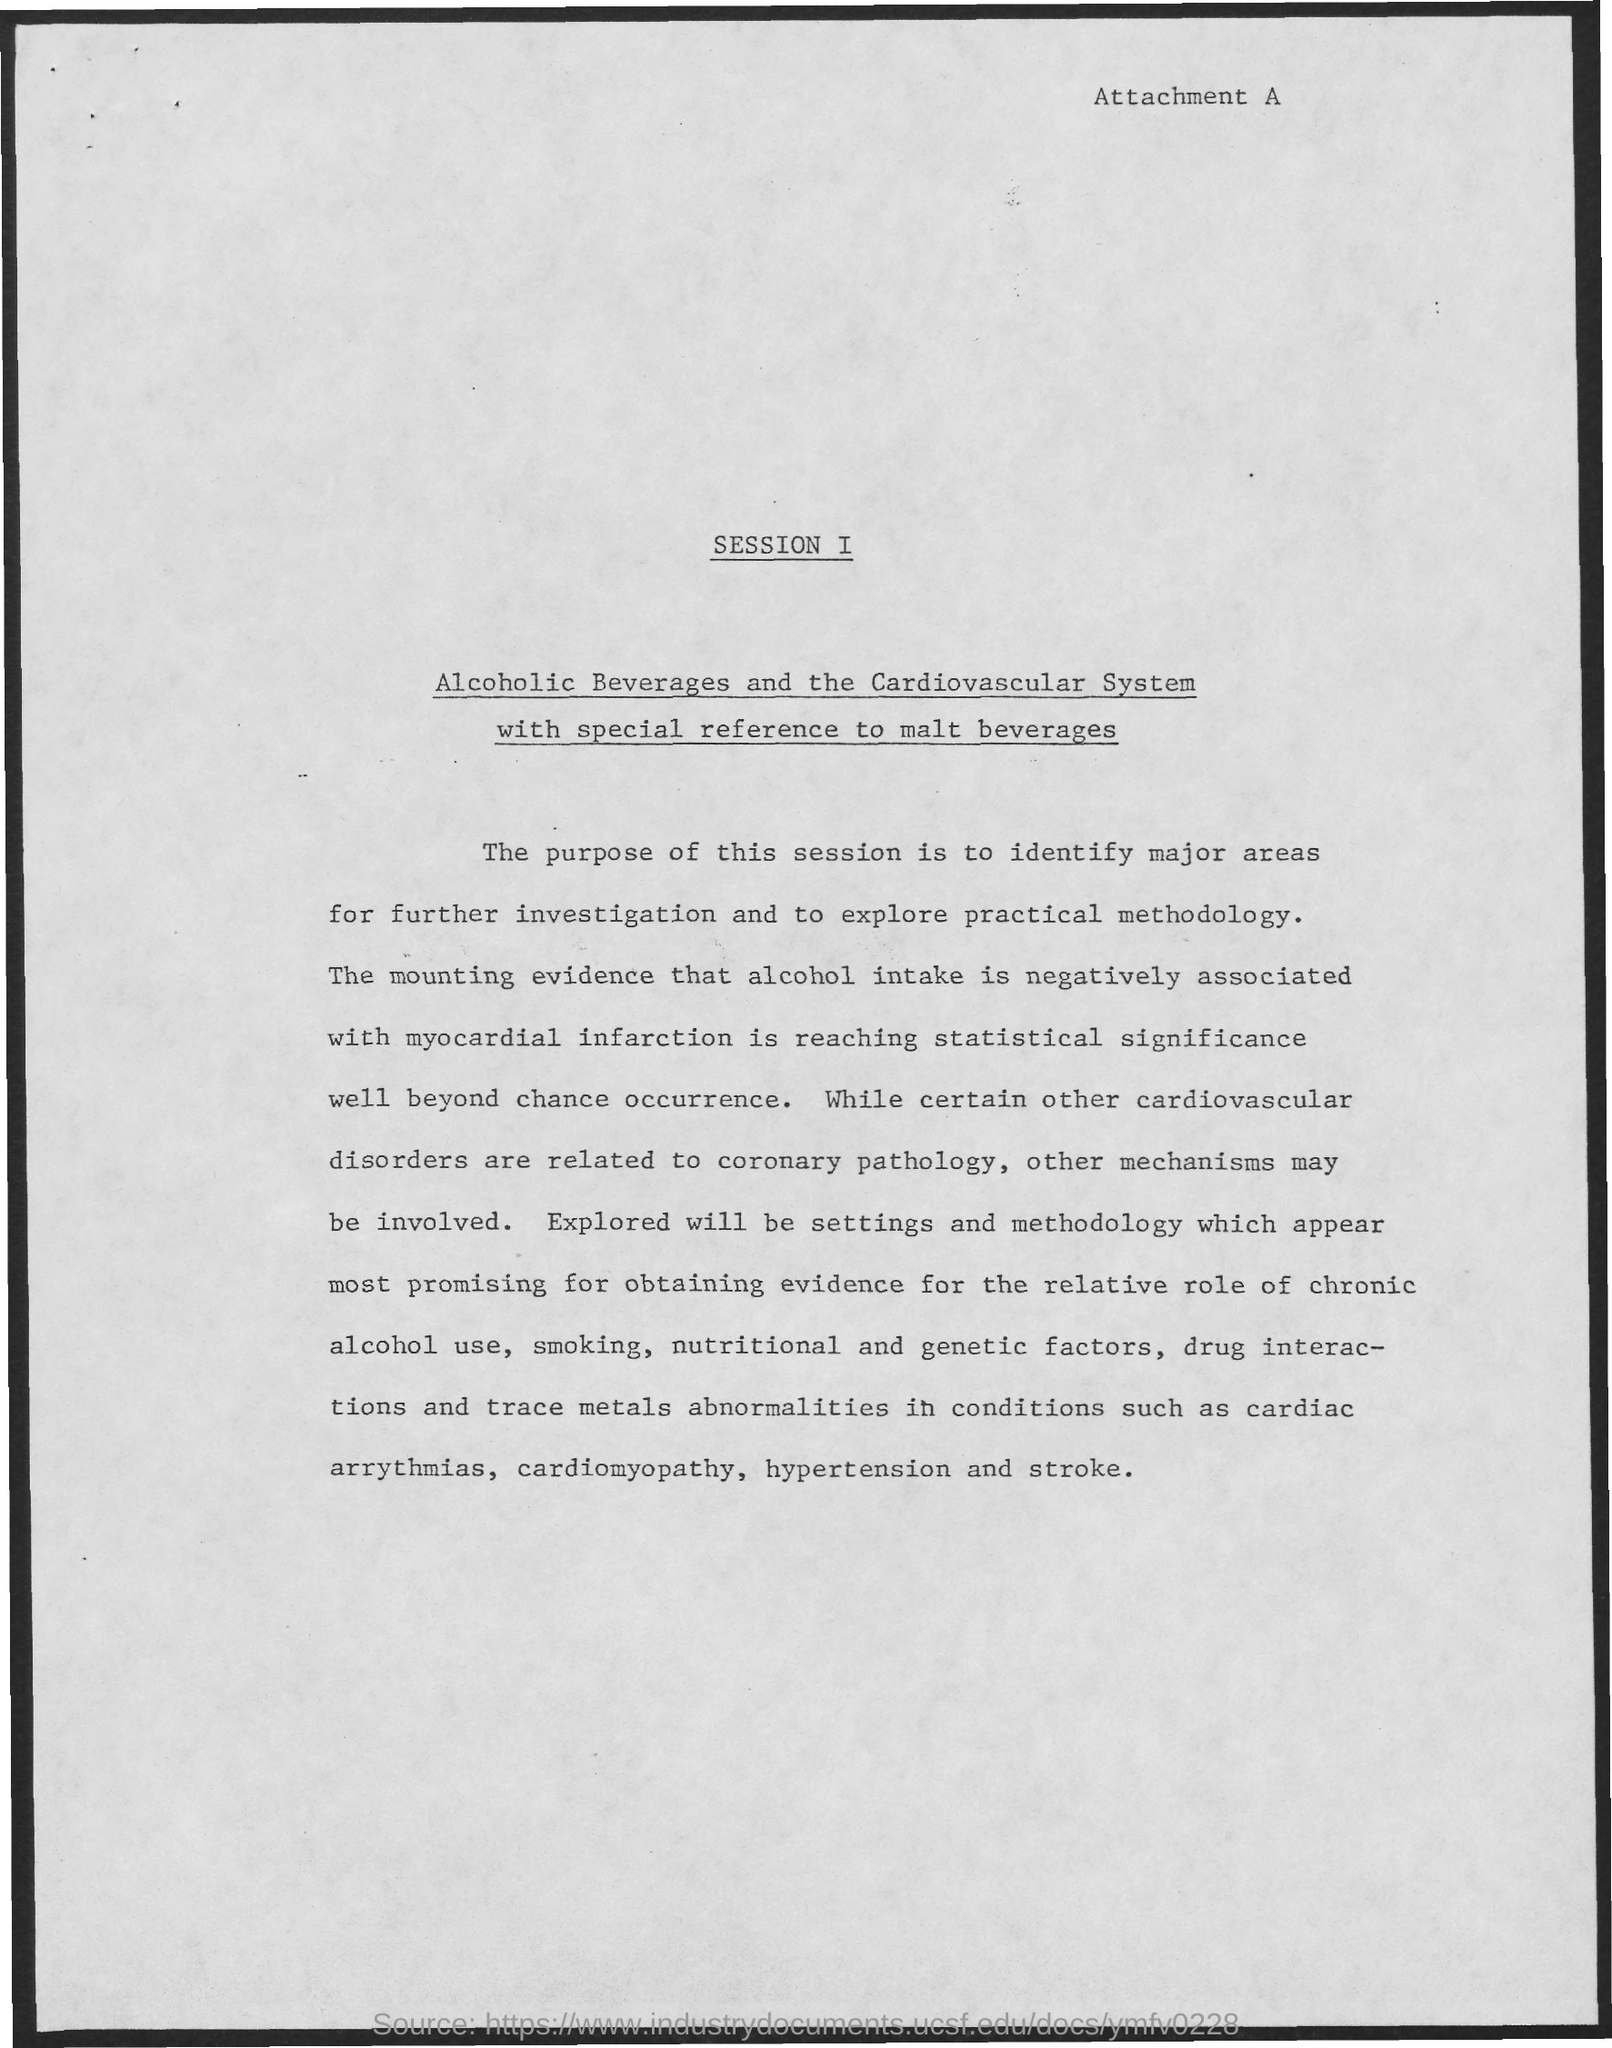What is written at the top right corner of this document?
Your response must be concise. Attachment A. What is purpose of the session ?
Make the answer very short. To identify major areas for further investigation and to explore practical methodology. What is the title of the document which is written below the heading "Session I" ?
Keep it short and to the point. Alcoholic Beverages and the Cardiovascular System with special reference to malt beverages. What is negatively associated with myocardial infarction?
Ensure brevity in your answer.  Alcohol intake. What is the purpose of the session?
Provide a succinct answer. To identify major areas for further investigation and to explore practical methodology. What is written on top right side of the document ?
Keep it short and to the point. Attachment A. What is the heading shown in top middle of the document ?
Provide a short and direct response. SESSION I. 